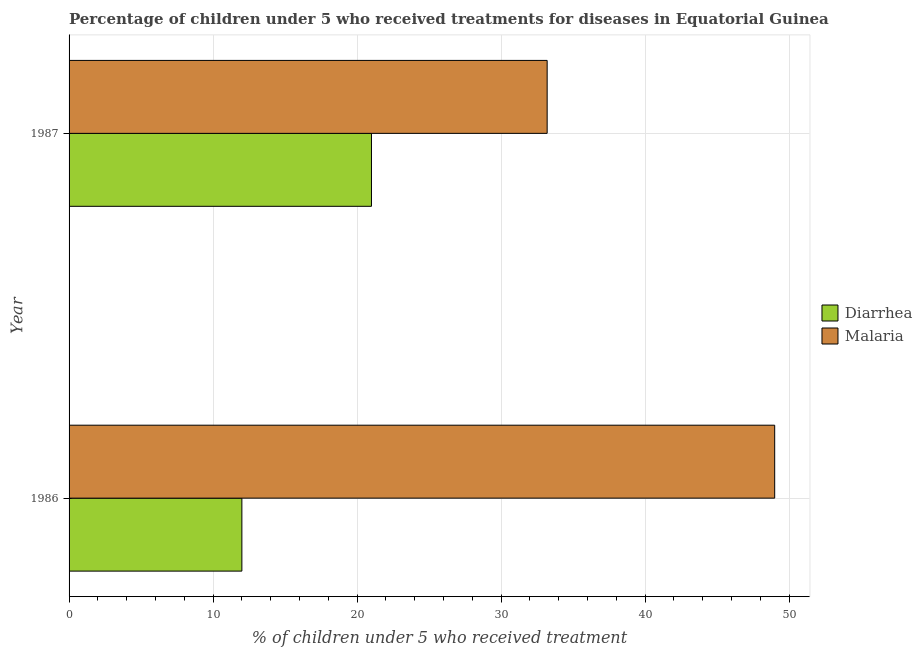How many groups of bars are there?
Your response must be concise. 2. Are the number of bars per tick equal to the number of legend labels?
Your response must be concise. Yes. How many bars are there on the 1st tick from the bottom?
Make the answer very short. 2. What is the label of the 2nd group of bars from the top?
Give a very brief answer. 1986. In how many cases, is the number of bars for a given year not equal to the number of legend labels?
Provide a succinct answer. 0. What is the percentage of children who received treatment for malaria in 1987?
Make the answer very short. 33.2. Across all years, what is the maximum percentage of children who received treatment for diarrhoea?
Offer a very short reply. 21. Across all years, what is the minimum percentage of children who received treatment for malaria?
Ensure brevity in your answer.  33.2. In which year was the percentage of children who received treatment for diarrhoea maximum?
Your answer should be very brief. 1987. In which year was the percentage of children who received treatment for malaria minimum?
Your answer should be very brief. 1987. What is the total percentage of children who received treatment for diarrhoea in the graph?
Make the answer very short. 33. What is the difference between the percentage of children who received treatment for diarrhoea in 1986 and that in 1987?
Make the answer very short. -9. What is the difference between the percentage of children who received treatment for diarrhoea in 1987 and the percentage of children who received treatment for malaria in 1986?
Your response must be concise. -28. In the year 1987, what is the difference between the percentage of children who received treatment for diarrhoea and percentage of children who received treatment for malaria?
Ensure brevity in your answer.  -12.2. What is the ratio of the percentage of children who received treatment for malaria in 1986 to that in 1987?
Your response must be concise. 1.48. In how many years, is the percentage of children who received treatment for diarrhoea greater than the average percentage of children who received treatment for diarrhoea taken over all years?
Your answer should be very brief. 1. What does the 2nd bar from the top in 1986 represents?
Offer a terse response. Diarrhea. What does the 2nd bar from the bottom in 1986 represents?
Provide a succinct answer. Malaria. How many bars are there?
Your answer should be compact. 4. How many years are there in the graph?
Make the answer very short. 2. Are the values on the major ticks of X-axis written in scientific E-notation?
Your answer should be compact. No. Does the graph contain grids?
Your answer should be very brief. Yes. What is the title of the graph?
Your answer should be very brief. Percentage of children under 5 who received treatments for diseases in Equatorial Guinea. What is the label or title of the X-axis?
Your response must be concise. % of children under 5 who received treatment. What is the % of children under 5 who received treatment of Diarrhea in 1987?
Your answer should be compact. 21. What is the % of children under 5 who received treatment of Malaria in 1987?
Keep it short and to the point. 33.2. Across all years, what is the maximum % of children under 5 who received treatment in Malaria?
Give a very brief answer. 49. Across all years, what is the minimum % of children under 5 who received treatment of Diarrhea?
Offer a very short reply. 12. Across all years, what is the minimum % of children under 5 who received treatment in Malaria?
Ensure brevity in your answer.  33.2. What is the total % of children under 5 who received treatment of Diarrhea in the graph?
Provide a short and direct response. 33. What is the total % of children under 5 who received treatment in Malaria in the graph?
Your answer should be compact. 82.2. What is the difference between the % of children under 5 who received treatment of Diarrhea in 1986 and the % of children under 5 who received treatment of Malaria in 1987?
Ensure brevity in your answer.  -21.2. What is the average % of children under 5 who received treatment of Malaria per year?
Make the answer very short. 41.1. In the year 1986, what is the difference between the % of children under 5 who received treatment in Diarrhea and % of children under 5 who received treatment in Malaria?
Provide a short and direct response. -37. What is the ratio of the % of children under 5 who received treatment of Diarrhea in 1986 to that in 1987?
Your response must be concise. 0.57. What is the ratio of the % of children under 5 who received treatment in Malaria in 1986 to that in 1987?
Your response must be concise. 1.48. What is the difference between the highest and the second highest % of children under 5 who received treatment in Diarrhea?
Make the answer very short. 9. What is the difference between the highest and the second highest % of children under 5 who received treatment of Malaria?
Your answer should be very brief. 15.8. What is the difference between the highest and the lowest % of children under 5 who received treatment in Malaria?
Your answer should be compact. 15.8. 